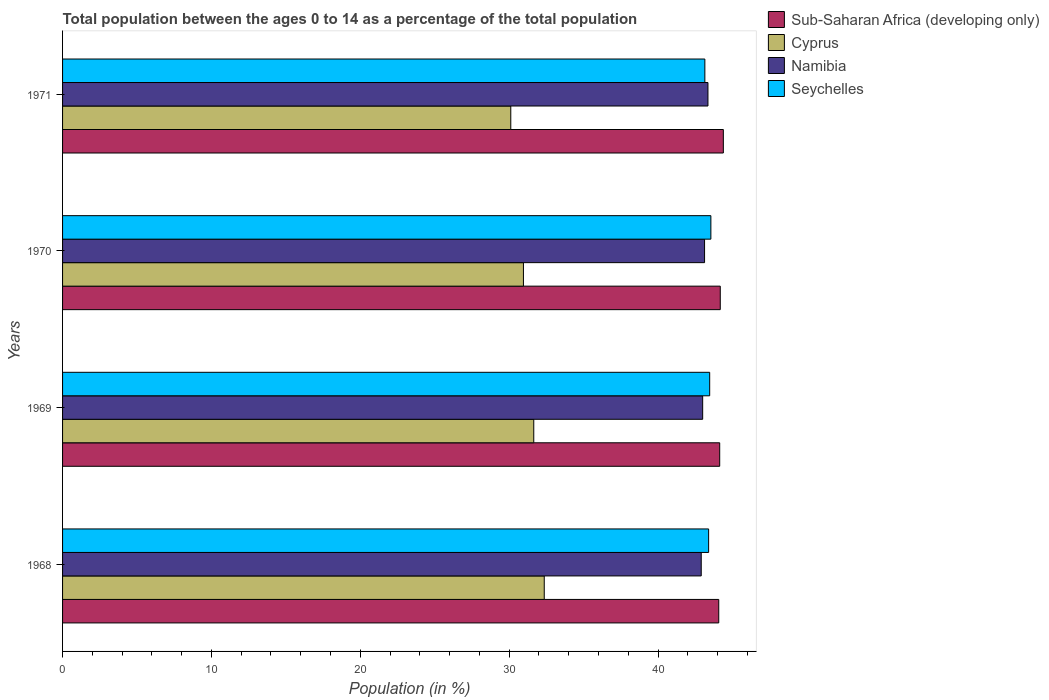How many different coloured bars are there?
Make the answer very short. 4. Are the number of bars on each tick of the Y-axis equal?
Your answer should be compact. Yes. How many bars are there on the 1st tick from the top?
Offer a very short reply. 4. How many bars are there on the 3rd tick from the bottom?
Ensure brevity in your answer.  4. What is the label of the 4th group of bars from the top?
Offer a terse response. 1968. In how many cases, is the number of bars for a given year not equal to the number of legend labels?
Offer a very short reply. 0. What is the percentage of the population ages 0 to 14 in Namibia in 1969?
Offer a terse response. 43. Across all years, what is the maximum percentage of the population ages 0 to 14 in Sub-Saharan Africa (developing only)?
Keep it short and to the point. 44.39. Across all years, what is the minimum percentage of the population ages 0 to 14 in Namibia?
Your answer should be very brief. 42.9. In which year was the percentage of the population ages 0 to 14 in Namibia minimum?
Your answer should be compact. 1968. What is the total percentage of the population ages 0 to 14 in Seychelles in the graph?
Your response must be concise. 173.57. What is the difference between the percentage of the population ages 0 to 14 in Cyprus in 1969 and that in 1970?
Keep it short and to the point. 0.69. What is the difference between the percentage of the population ages 0 to 14 in Seychelles in 1970 and the percentage of the population ages 0 to 14 in Sub-Saharan Africa (developing only) in 1969?
Give a very brief answer. -0.59. What is the average percentage of the population ages 0 to 14 in Seychelles per year?
Your answer should be very brief. 43.39. In the year 1970, what is the difference between the percentage of the population ages 0 to 14 in Seychelles and percentage of the population ages 0 to 14 in Sub-Saharan Africa (developing only)?
Your answer should be compact. -0.63. What is the ratio of the percentage of the population ages 0 to 14 in Cyprus in 1968 to that in 1971?
Keep it short and to the point. 1.07. Is the percentage of the population ages 0 to 14 in Seychelles in 1969 less than that in 1971?
Provide a succinct answer. No. Is the difference between the percentage of the population ages 0 to 14 in Seychelles in 1969 and 1970 greater than the difference between the percentage of the population ages 0 to 14 in Sub-Saharan Africa (developing only) in 1969 and 1970?
Ensure brevity in your answer.  No. What is the difference between the highest and the second highest percentage of the population ages 0 to 14 in Namibia?
Provide a succinct answer. 0.23. What is the difference between the highest and the lowest percentage of the population ages 0 to 14 in Seychelles?
Keep it short and to the point. 0.4. In how many years, is the percentage of the population ages 0 to 14 in Sub-Saharan Africa (developing only) greater than the average percentage of the population ages 0 to 14 in Sub-Saharan Africa (developing only) taken over all years?
Your answer should be very brief. 1. Is it the case that in every year, the sum of the percentage of the population ages 0 to 14 in Namibia and percentage of the population ages 0 to 14 in Sub-Saharan Africa (developing only) is greater than the sum of percentage of the population ages 0 to 14 in Cyprus and percentage of the population ages 0 to 14 in Seychelles?
Keep it short and to the point. No. What does the 3rd bar from the top in 1969 represents?
Provide a succinct answer. Cyprus. What does the 2nd bar from the bottom in 1970 represents?
Offer a very short reply. Cyprus. How many years are there in the graph?
Give a very brief answer. 4. How many legend labels are there?
Provide a short and direct response. 4. What is the title of the graph?
Offer a very short reply. Total population between the ages 0 to 14 as a percentage of the total population. Does "Uruguay" appear as one of the legend labels in the graph?
Your response must be concise. No. What is the label or title of the X-axis?
Offer a very short reply. Population (in %). What is the label or title of the Y-axis?
Give a very brief answer. Years. What is the Population (in %) in Sub-Saharan Africa (developing only) in 1968?
Offer a terse response. 44.08. What is the Population (in %) in Cyprus in 1968?
Your response must be concise. 32.36. What is the Population (in %) in Namibia in 1968?
Your answer should be compact. 42.9. What is the Population (in %) of Seychelles in 1968?
Offer a very short reply. 43.4. What is the Population (in %) of Sub-Saharan Africa (developing only) in 1969?
Your response must be concise. 44.14. What is the Population (in %) in Cyprus in 1969?
Keep it short and to the point. 31.65. What is the Population (in %) of Namibia in 1969?
Offer a very short reply. 43. What is the Population (in %) of Seychelles in 1969?
Your answer should be compact. 43.47. What is the Population (in %) in Sub-Saharan Africa (developing only) in 1970?
Offer a terse response. 44.18. What is the Population (in %) of Cyprus in 1970?
Provide a succinct answer. 30.96. What is the Population (in %) in Namibia in 1970?
Your response must be concise. 43.13. What is the Population (in %) of Seychelles in 1970?
Give a very brief answer. 43.55. What is the Population (in %) in Sub-Saharan Africa (developing only) in 1971?
Offer a very short reply. 44.39. What is the Population (in %) of Cyprus in 1971?
Your response must be concise. 30.11. What is the Population (in %) in Namibia in 1971?
Your answer should be very brief. 43.35. What is the Population (in %) in Seychelles in 1971?
Keep it short and to the point. 43.15. Across all years, what is the maximum Population (in %) in Sub-Saharan Africa (developing only)?
Provide a succinct answer. 44.39. Across all years, what is the maximum Population (in %) of Cyprus?
Your answer should be compact. 32.36. Across all years, what is the maximum Population (in %) of Namibia?
Make the answer very short. 43.35. Across all years, what is the maximum Population (in %) of Seychelles?
Your answer should be compact. 43.55. Across all years, what is the minimum Population (in %) of Sub-Saharan Africa (developing only)?
Your response must be concise. 44.08. Across all years, what is the minimum Population (in %) of Cyprus?
Give a very brief answer. 30.11. Across all years, what is the minimum Population (in %) of Namibia?
Keep it short and to the point. 42.9. Across all years, what is the minimum Population (in %) in Seychelles?
Offer a terse response. 43.15. What is the total Population (in %) in Sub-Saharan Africa (developing only) in the graph?
Provide a short and direct response. 176.79. What is the total Population (in %) of Cyprus in the graph?
Ensure brevity in your answer.  125.08. What is the total Population (in %) of Namibia in the graph?
Provide a short and direct response. 172.38. What is the total Population (in %) in Seychelles in the graph?
Offer a terse response. 173.57. What is the difference between the Population (in %) of Sub-Saharan Africa (developing only) in 1968 and that in 1969?
Offer a very short reply. -0.06. What is the difference between the Population (in %) in Cyprus in 1968 and that in 1969?
Ensure brevity in your answer.  0.7. What is the difference between the Population (in %) in Namibia in 1968 and that in 1969?
Ensure brevity in your answer.  -0.1. What is the difference between the Population (in %) of Seychelles in 1968 and that in 1969?
Offer a terse response. -0.07. What is the difference between the Population (in %) in Sub-Saharan Africa (developing only) in 1968 and that in 1970?
Give a very brief answer. -0.1. What is the difference between the Population (in %) in Cyprus in 1968 and that in 1970?
Offer a very short reply. 1.4. What is the difference between the Population (in %) of Namibia in 1968 and that in 1970?
Ensure brevity in your answer.  -0.22. What is the difference between the Population (in %) in Seychelles in 1968 and that in 1970?
Make the answer very short. -0.15. What is the difference between the Population (in %) in Sub-Saharan Africa (developing only) in 1968 and that in 1971?
Your response must be concise. -0.31. What is the difference between the Population (in %) of Cyprus in 1968 and that in 1971?
Your response must be concise. 2.25. What is the difference between the Population (in %) in Namibia in 1968 and that in 1971?
Ensure brevity in your answer.  -0.45. What is the difference between the Population (in %) in Seychelles in 1968 and that in 1971?
Make the answer very short. 0.25. What is the difference between the Population (in %) in Sub-Saharan Africa (developing only) in 1969 and that in 1970?
Keep it short and to the point. -0.04. What is the difference between the Population (in %) in Cyprus in 1969 and that in 1970?
Ensure brevity in your answer.  0.69. What is the difference between the Population (in %) of Namibia in 1969 and that in 1970?
Keep it short and to the point. -0.13. What is the difference between the Population (in %) of Seychelles in 1969 and that in 1970?
Your answer should be compact. -0.08. What is the difference between the Population (in %) of Sub-Saharan Africa (developing only) in 1969 and that in 1971?
Keep it short and to the point. -0.24. What is the difference between the Population (in %) of Cyprus in 1969 and that in 1971?
Ensure brevity in your answer.  1.54. What is the difference between the Population (in %) of Namibia in 1969 and that in 1971?
Offer a very short reply. -0.35. What is the difference between the Population (in %) in Seychelles in 1969 and that in 1971?
Ensure brevity in your answer.  0.32. What is the difference between the Population (in %) of Sub-Saharan Africa (developing only) in 1970 and that in 1971?
Your response must be concise. -0.21. What is the difference between the Population (in %) in Cyprus in 1970 and that in 1971?
Your answer should be very brief. 0.85. What is the difference between the Population (in %) of Namibia in 1970 and that in 1971?
Give a very brief answer. -0.23. What is the difference between the Population (in %) in Seychelles in 1970 and that in 1971?
Your response must be concise. 0.4. What is the difference between the Population (in %) of Sub-Saharan Africa (developing only) in 1968 and the Population (in %) of Cyprus in 1969?
Offer a very short reply. 12.43. What is the difference between the Population (in %) of Sub-Saharan Africa (developing only) in 1968 and the Population (in %) of Namibia in 1969?
Offer a very short reply. 1.08. What is the difference between the Population (in %) in Sub-Saharan Africa (developing only) in 1968 and the Population (in %) in Seychelles in 1969?
Provide a short and direct response. 0.61. What is the difference between the Population (in %) in Cyprus in 1968 and the Population (in %) in Namibia in 1969?
Provide a succinct answer. -10.64. What is the difference between the Population (in %) of Cyprus in 1968 and the Population (in %) of Seychelles in 1969?
Give a very brief answer. -11.11. What is the difference between the Population (in %) in Namibia in 1968 and the Population (in %) in Seychelles in 1969?
Provide a short and direct response. -0.57. What is the difference between the Population (in %) of Sub-Saharan Africa (developing only) in 1968 and the Population (in %) of Cyprus in 1970?
Offer a terse response. 13.12. What is the difference between the Population (in %) in Sub-Saharan Africa (developing only) in 1968 and the Population (in %) in Namibia in 1970?
Your answer should be very brief. 0.95. What is the difference between the Population (in %) in Sub-Saharan Africa (developing only) in 1968 and the Population (in %) in Seychelles in 1970?
Offer a terse response. 0.53. What is the difference between the Population (in %) in Cyprus in 1968 and the Population (in %) in Namibia in 1970?
Your answer should be very brief. -10.77. What is the difference between the Population (in %) in Cyprus in 1968 and the Population (in %) in Seychelles in 1970?
Provide a short and direct response. -11.19. What is the difference between the Population (in %) of Namibia in 1968 and the Population (in %) of Seychelles in 1970?
Ensure brevity in your answer.  -0.65. What is the difference between the Population (in %) in Sub-Saharan Africa (developing only) in 1968 and the Population (in %) in Cyprus in 1971?
Your answer should be very brief. 13.97. What is the difference between the Population (in %) in Sub-Saharan Africa (developing only) in 1968 and the Population (in %) in Namibia in 1971?
Give a very brief answer. 0.73. What is the difference between the Population (in %) in Sub-Saharan Africa (developing only) in 1968 and the Population (in %) in Seychelles in 1971?
Offer a terse response. 0.93. What is the difference between the Population (in %) in Cyprus in 1968 and the Population (in %) in Namibia in 1971?
Ensure brevity in your answer.  -11. What is the difference between the Population (in %) of Cyprus in 1968 and the Population (in %) of Seychelles in 1971?
Offer a very short reply. -10.79. What is the difference between the Population (in %) in Namibia in 1968 and the Population (in %) in Seychelles in 1971?
Keep it short and to the point. -0.24. What is the difference between the Population (in %) of Sub-Saharan Africa (developing only) in 1969 and the Population (in %) of Cyprus in 1970?
Keep it short and to the point. 13.18. What is the difference between the Population (in %) of Sub-Saharan Africa (developing only) in 1969 and the Population (in %) of Namibia in 1970?
Provide a short and direct response. 1.02. What is the difference between the Population (in %) in Sub-Saharan Africa (developing only) in 1969 and the Population (in %) in Seychelles in 1970?
Offer a very short reply. 0.59. What is the difference between the Population (in %) in Cyprus in 1969 and the Population (in %) in Namibia in 1970?
Offer a very short reply. -11.47. What is the difference between the Population (in %) of Cyprus in 1969 and the Population (in %) of Seychelles in 1970?
Provide a short and direct response. -11.9. What is the difference between the Population (in %) in Namibia in 1969 and the Population (in %) in Seychelles in 1970?
Make the answer very short. -0.55. What is the difference between the Population (in %) of Sub-Saharan Africa (developing only) in 1969 and the Population (in %) of Cyprus in 1971?
Make the answer very short. 14.03. What is the difference between the Population (in %) of Sub-Saharan Africa (developing only) in 1969 and the Population (in %) of Namibia in 1971?
Make the answer very short. 0.79. What is the difference between the Population (in %) in Sub-Saharan Africa (developing only) in 1969 and the Population (in %) in Seychelles in 1971?
Provide a short and direct response. 1. What is the difference between the Population (in %) of Cyprus in 1969 and the Population (in %) of Namibia in 1971?
Offer a terse response. -11.7. What is the difference between the Population (in %) of Cyprus in 1969 and the Population (in %) of Seychelles in 1971?
Your answer should be very brief. -11.49. What is the difference between the Population (in %) in Namibia in 1969 and the Population (in %) in Seychelles in 1971?
Make the answer very short. -0.15. What is the difference between the Population (in %) of Sub-Saharan Africa (developing only) in 1970 and the Population (in %) of Cyprus in 1971?
Your response must be concise. 14.07. What is the difference between the Population (in %) in Sub-Saharan Africa (developing only) in 1970 and the Population (in %) in Namibia in 1971?
Offer a very short reply. 0.83. What is the difference between the Population (in %) of Sub-Saharan Africa (developing only) in 1970 and the Population (in %) of Seychelles in 1971?
Your answer should be compact. 1.04. What is the difference between the Population (in %) of Cyprus in 1970 and the Population (in %) of Namibia in 1971?
Provide a succinct answer. -12.39. What is the difference between the Population (in %) in Cyprus in 1970 and the Population (in %) in Seychelles in 1971?
Your response must be concise. -12.19. What is the difference between the Population (in %) in Namibia in 1970 and the Population (in %) in Seychelles in 1971?
Make the answer very short. -0.02. What is the average Population (in %) of Sub-Saharan Africa (developing only) per year?
Give a very brief answer. 44.2. What is the average Population (in %) in Cyprus per year?
Offer a very short reply. 31.27. What is the average Population (in %) in Namibia per year?
Your answer should be very brief. 43.1. What is the average Population (in %) of Seychelles per year?
Offer a terse response. 43.39. In the year 1968, what is the difference between the Population (in %) of Sub-Saharan Africa (developing only) and Population (in %) of Cyprus?
Make the answer very short. 11.72. In the year 1968, what is the difference between the Population (in %) in Sub-Saharan Africa (developing only) and Population (in %) in Namibia?
Offer a very short reply. 1.18. In the year 1968, what is the difference between the Population (in %) of Sub-Saharan Africa (developing only) and Population (in %) of Seychelles?
Offer a terse response. 0.68. In the year 1968, what is the difference between the Population (in %) in Cyprus and Population (in %) in Namibia?
Your answer should be compact. -10.55. In the year 1968, what is the difference between the Population (in %) in Cyprus and Population (in %) in Seychelles?
Offer a very short reply. -11.04. In the year 1968, what is the difference between the Population (in %) in Namibia and Population (in %) in Seychelles?
Ensure brevity in your answer.  -0.5. In the year 1969, what is the difference between the Population (in %) of Sub-Saharan Africa (developing only) and Population (in %) of Cyprus?
Keep it short and to the point. 12.49. In the year 1969, what is the difference between the Population (in %) in Sub-Saharan Africa (developing only) and Population (in %) in Namibia?
Give a very brief answer. 1.14. In the year 1969, what is the difference between the Population (in %) in Sub-Saharan Africa (developing only) and Population (in %) in Seychelles?
Provide a short and direct response. 0.67. In the year 1969, what is the difference between the Population (in %) in Cyprus and Population (in %) in Namibia?
Provide a succinct answer. -11.35. In the year 1969, what is the difference between the Population (in %) of Cyprus and Population (in %) of Seychelles?
Make the answer very short. -11.82. In the year 1969, what is the difference between the Population (in %) in Namibia and Population (in %) in Seychelles?
Provide a succinct answer. -0.47. In the year 1970, what is the difference between the Population (in %) in Sub-Saharan Africa (developing only) and Population (in %) in Cyprus?
Offer a very short reply. 13.22. In the year 1970, what is the difference between the Population (in %) of Sub-Saharan Africa (developing only) and Population (in %) of Namibia?
Your answer should be very brief. 1.05. In the year 1970, what is the difference between the Population (in %) of Sub-Saharan Africa (developing only) and Population (in %) of Seychelles?
Your answer should be compact. 0.63. In the year 1970, what is the difference between the Population (in %) in Cyprus and Population (in %) in Namibia?
Offer a very short reply. -12.17. In the year 1970, what is the difference between the Population (in %) of Cyprus and Population (in %) of Seychelles?
Offer a very short reply. -12.59. In the year 1970, what is the difference between the Population (in %) in Namibia and Population (in %) in Seychelles?
Provide a short and direct response. -0.42. In the year 1971, what is the difference between the Population (in %) of Sub-Saharan Africa (developing only) and Population (in %) of Cyprus?
Your answer should be very brief. 14.28. In the year 1971, what is the difference between the Population (in %) of Sub-Saharan Africa (developing only) and Population (in %) of Namibia?
Your answer should be very brief. 1.03. In the year 1971, what is the difference between the Population (in %) of Sub-Saharan Africa (developing only) and Population (in %) of Seychelles?
Your answer should be very brief. 1.24. In the year 1971, what is the difference between the Population (in %) of Cyprus and Population (in %) of Namibia?
Offer a very short reply. -13.24. In the year 1971, what is the difference between the Population (in %) of Cyprus and Population (in %) of Seychelles?
Your answer should be compact. -13.04. In the year 1971, what is the difference between the Population (in %) of Namibia and Population (in %) of Seychelles?
Offer a very short reply. 0.21. What is the ratio of the Population (in %) in Cyprus in 1968 to that in 1969?
Provide a short and direct response. 1.02. What is the ratio of the Population (in %) in Namibia in 1968 to that in 1969?
Your response must be concise. 1. What is the ratio of the Population (in %) in Sub-Saharan Africa (developing only) in 1968 to that in 1970?
Offer a terse response. 1. What is the ratio of the Population (in %) of Cyprus in 1968 to that in 1970?
Your response must be concise. 1.05. What is the ratio of the Population (in %) in Namibia in 1968 to that in 1970?
Provide a succinct answer. 0.99. What is the ratio of the Population (in %) of Seychelles in 1968 to that in 1970?
Keep it short and to the point. 1. What is the ratio of the Population (in %) of Sub-Saharan Africa (developing only) in 1968 to that in 1971?
Ensure brevity in your answer.  0.99. What is the ratio of the Population (in %) in Cyprus in 1968 to that in 1971?
Ensure brevity in your answer.  1.07. What is the ratio of the Population (in %) of Seychelles in 1968 to that in 1971?
Offer a terse response. 1.01. What is the ratio of the Population (in %) of Sub-Saharan Africa (developing only) in 1969 to that in 1970?
Your answer should be very brief. 1. What is the ratio of the Population (in %) of Cyprus in 1969 to that in 1970?
Ensure brevity in your answer.  1.02. What is the ratio of the Population (in %) of Seychelles in 1969 to that in 1970?
Ensure brevity in your answer.  1. What is the ratio of the Population (in %) in Sub-Saharan Africa (developing only) in 1969 to that in 1971?
Your answer should be very brief. 0.99. What is the ratio of the Population (in %) in Cyprus in 1969 to that in 1971?
Offer a very short reply. 1.05. What is the ratio of the Population (in %) of Seychelles in 1969 to that in 1971?
Keep it short and to the point. 1.01. What is the ratio of the Population (in %) of Cyprus in 1970 to that in 1971?
Your response must be concise. 1.03. What is the ratio of the Population (in %) of Seychelles in 1970 to that in 1971?
Offer a terse response. 1.01. What is the difference between the highest and the second highest Population (in %) in Sub-Saharan Africa (developing only)?
Your response must be concise. 0.21. What is the difference between the highest and the second highest Population (in %) of Cyprus?
Your answer should be very brief. 0.7. What is the difference between the highest and the second highest Population (in %) of Namibia?
Your response must be concise. 0.23. What is the difference between the highest and the second highest Population (in %) in Seychelles?
Ensure brevity in your answer.  0.08. What is the difference between the highest and the lowest Population (in %) of Sub-Saharan Africa (developing only)?
Your answer should be compact. 0.31. What is the difference between the highest and the lowest Population (in %) in Cyprus?
Your answer should be very brief. 2.25. What is the difference between the highest and the lowest Population (in %) in Namibia?
Provide a succinct answer. 0.45. What is the difference between the highest and the lowest Population (in %) in Seychelles?
Ensure brevity in your answer.  0.4. 